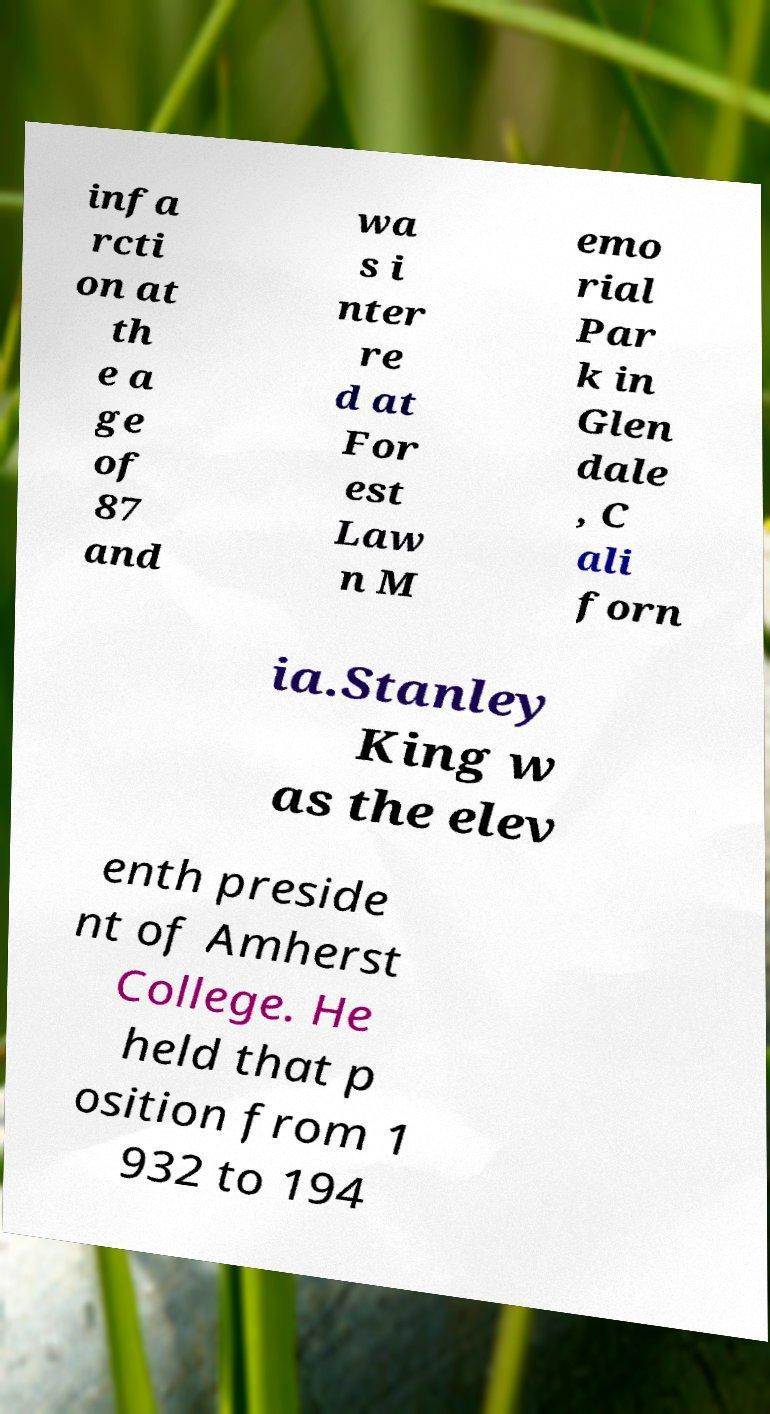Could you extract and type out the text from this image? infa rcti on at th e a ge of 87 and wa s i nter re d at For est Law n M emo rial Par k in Glen dale , C ali forn ia.Stanley King w as the elev enth preside nt of Amherst College. He held that p osition from 1 932 to 194 